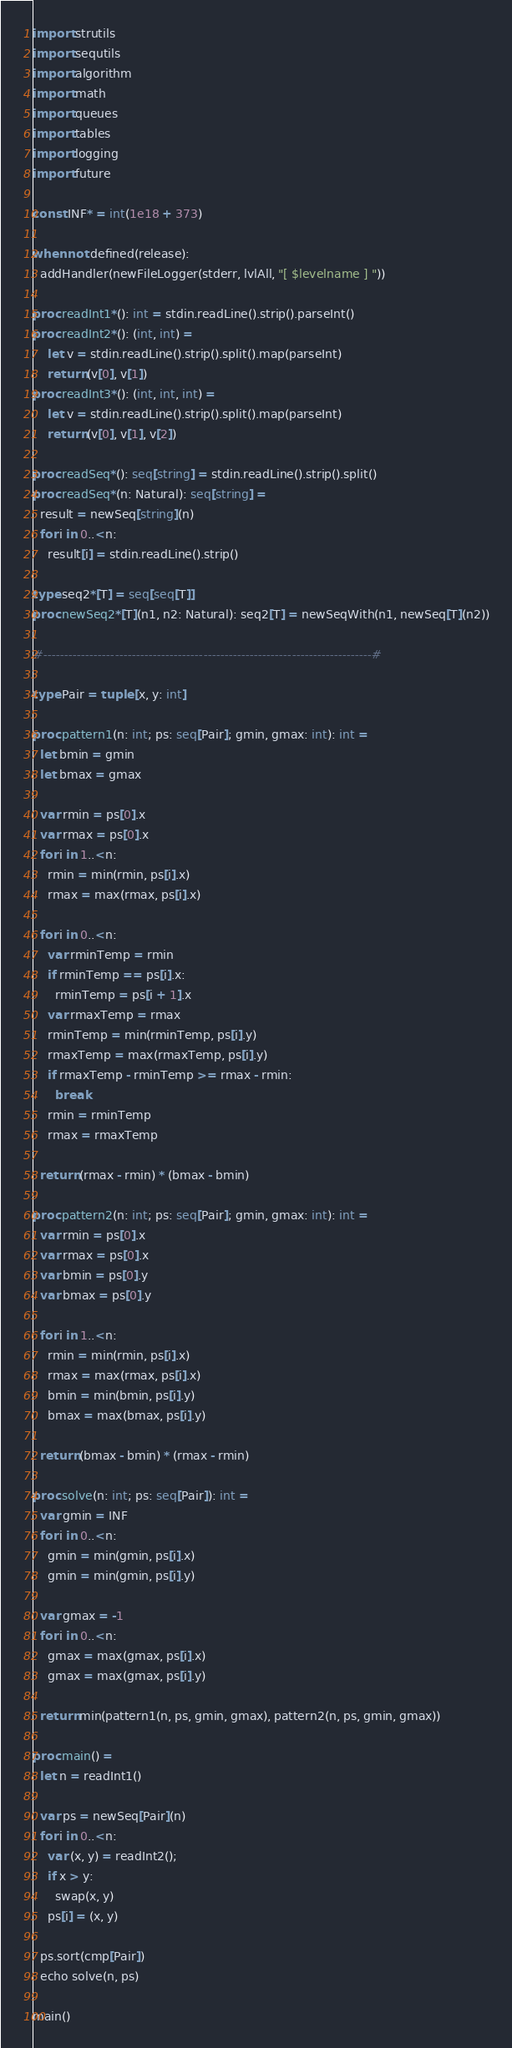Convert code to text. <code><loc_0><loc_0><loc_500><loc_500><_Nim_>import strutils
import sequtils
import algorithm
import math
import queues
import tables
import logging
import future

const INF* = int(1e18 + 373)

when not defined(release):
  addHandler(newFileLogger(stderr, lvlAll, "[ $levelname ] "))

proc readInt1*(): int = stdin.readLine().strip().parseInt()
proc readInt2*(): (int, int) =
    let v = stdin.readLine().strip().split().map(parseInt)
    return (v[0], v[1])
proc readInt3*(): (int, int, int) =
    let v = stdin.readLine().strip().split().map(parseInt)
    return (v[0], v[1], v[2])

proc readSeq*(): seq[string] = stdin.readLine().strip().split()
proc readSeq*(n: Natural): seq[string] =
  result = newSeq[string](n)
  for i in 0..<n:
    result[i] = stdin.readLine().strip()

type seq2*[T] = seq[seq[T]]
proc newSeq2*[T](n1, n2: Natural): seq2[T] = newSeqWith(n1, newSeq[T](n2))

#------------------------------------------------------------------------------#

type Pair = tuple [x, y: int]

proc pattern1(n: int; ps: seq[Pair]; gmin, gmax: int): int =
  let bmin = gmin
  let bmax = gmax

  var rmin = ps[0].x
  var rmax = ps[0].x
  for i in 1..<n:
    rmin = min(rmin, ps[i].x)
    rmax = max(rmax, ps[i].x)

  for i in 0..<n:
    var rminTemp = rmin
    if rminTemp == ps[i].x:
      rminTemp = ps[i + 1].x
    var rmaxTemp = rmax
    rminTemp = min(rminTemp, ps[i].y)
    rmaxTemp = max(rmaxTemp, ps[i].y)
    if rmaxTemp - rminTemp >= rmax - rmin:
      break
    rmin = rminTemp
    rmax = rmaxTemp

  return (rmax - rmin) * (bmax - bmin)

proc pattern2(n: int; ps: seq[Pair]; gmin, gmax: int): int =
  var rmin = ps[0].x
  var rmax = ps[0].x
  var bmin = ps[0].y
  var bmax = ps[0].y

  for i in 1..<n:
    rmin = min(rmin, ps[i].x)
    rmax = max(rmax, ps[i].x)
    bmin = min(bmin, ps[i].y)
    bmax = max(bmax, ps[i].y)

  return (bmax - bmin) * (rmax - rmin)

proc solve(n: int; ps: seq[Pair]): int =
  var gmin = INF
  for i in 0..<n:
    gmin = min(gmin, ps[i].x)
    gmin = min(gmin, ps[i].y)

  var gmax = -1
  for i in 0..<n:
    gmax = max(gmax, ps[i].x)
    gmax = max(gmax, ps[i].y)

  return min(pattern1(n, ps, gmin, gmax), pattern2(n, ps, gmin, gmax))

proc main() =
  let n = readInt1()

  var ps = newSeq[Pair](n)
  for i in 0..<n:
    var (x, y) = readInt2();
    if x > y:
      swap(x, y)
    ps[i] = (x, y)

  ps.sort(cmp[Pair])
  echo solve(n, ps)

main()

</code> 